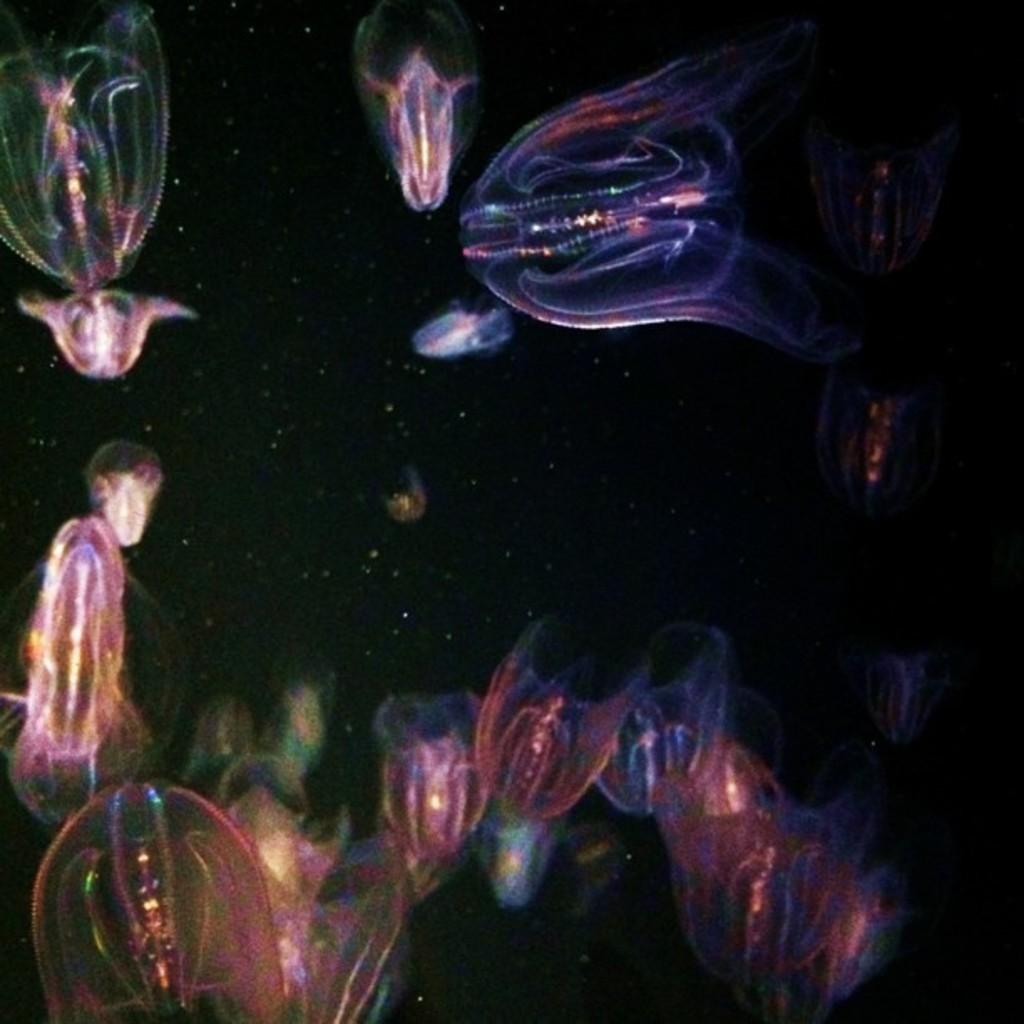What type of marine animals are in the water in the image? There are jellyfishes in the water in the image. What is the appearance of the jellyfishes? The jellyfishes are transparent. What unique characteristic do the jellyfishes exhibit? The jellyfishes exhibit fluorescence. What type of stamp can be seen on the jellyfishes in the image? There is no stamp present on the jellyfishes in the image. How does the porter feel about the jellyfishes in the image? There is no porter present in the image, so it is not possible to determine how they might feel about the jellyfishes. 